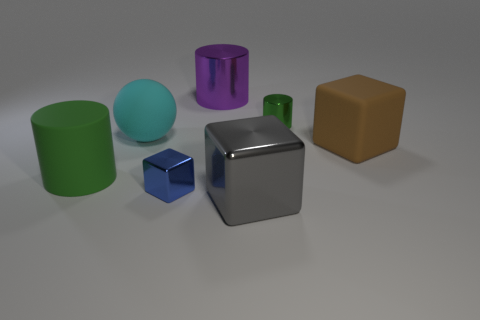Subtract all blue cylinders. Subtract all purple spheres. How many cylinders are left? 3 Add 3 large shiny cylinders. How many objects exist? 10 Subtract all cubes. How many objects are left? 4 Subtract all small blue metallic things. Subtract all big purple metallic things. How many objects are left? 5 Add 5 big objects. How many big objects are left? 10 Add 5 brown rubber cubes. How many brown rubber cubes exist? 6 Subtract 0 gray cylinders. How many objects are left? 7 